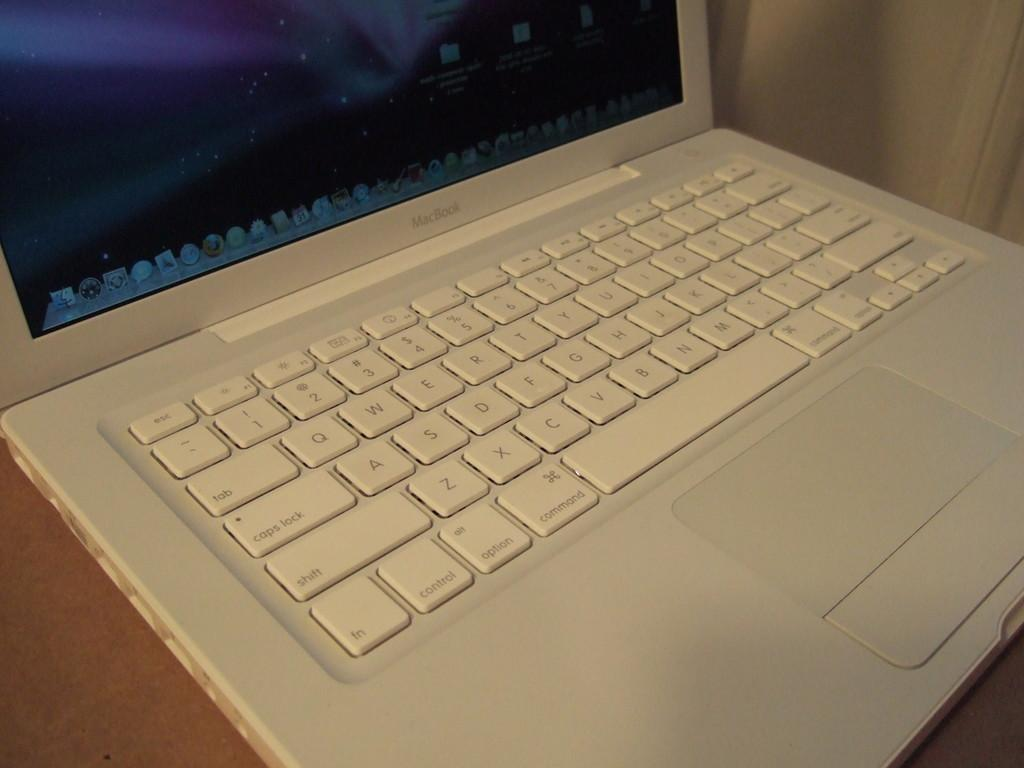<image>
Write a terse but informative summary of the picture. white macbook computer which is placed on the counter 